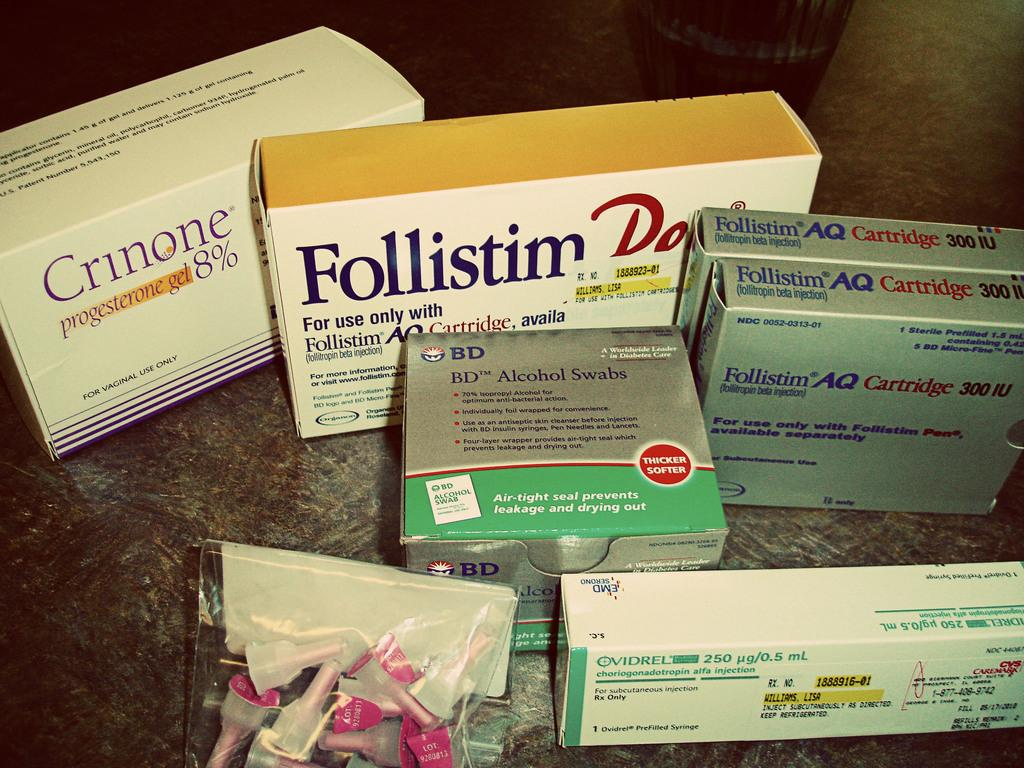<image>
Share a concise interpretation of the image provided. A few boxes of hormones are set on a table including Crinone and Follistim. 